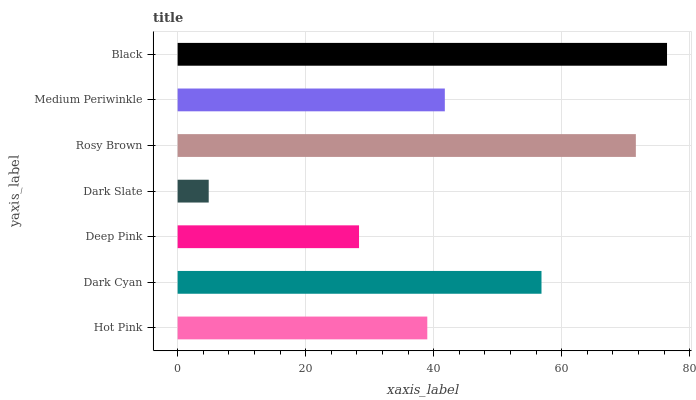Is Dark Slate the minimum?
Answer yes or no. Yes. Is Black the maximum?
Answer yes or no. Yes. Is Dark Cyan the minimum?
Answer yes or no. No. Is Dark Cyan the maximum?
Answer yes or no. No. Is Dark Cyan greater than Hot Pink?
Answer yes or no. Yes. Is Hot Pink less than Dark Cyan?
Answer yes or no. Yes. Is Hot Pink greater than Dark Cyan?
Answer yes or no. No. Is Dark Cyan less than Hot Pink?
Answer yes or no. No. Is Medium Periwinkle the high median?
Answer yes or no. Yes. Is Medium Periwinkle the low median?
Answer yes or no. Yes. Is Black the high median?
Answer yes or no. No. Is Black the low median?
Answer yes or no. No. 